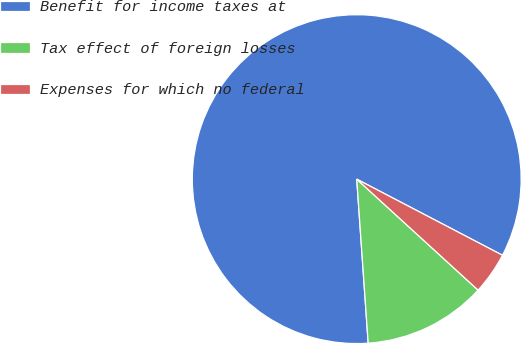Convert chart. <chart><loc_0><loc_0><loc_500><loc_500><pie_chart><fcel>Benefit for income taxes at<fcel>Tax effect of foreign losses<fcel>Expenses for which no federal<nl><fcel>83.77%<fcel>12.1%<fcel>4.13%<nl></chart> 